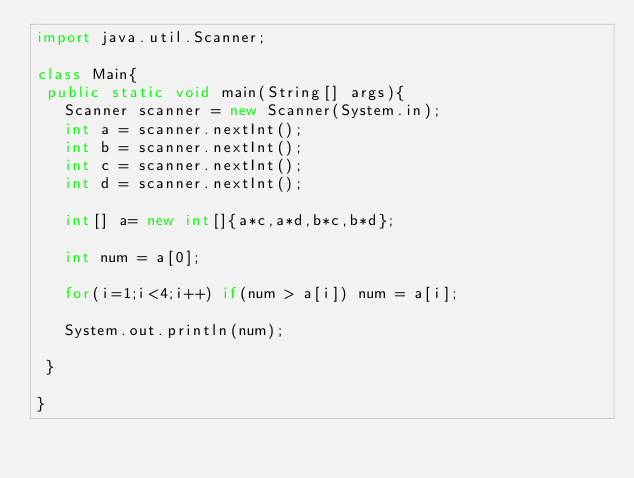Convert code to text. <code><loc_0><loc_0><loc_500><loc_500><_Java_>import java.util.Scanner;
 
class Main{
 public static void main(String[] args){
   Scanner scanner = new Scanner(System.in);
   int a = scanner.nextInt();
   int b = scanner.nextInt();
   int c = scanner.nextInt();
   int d = scanner.nextInt();
   
   int[] a= new int[]{a*c,a*d,b*c,b*d};
   
   int num = a[0];
   
   for(i=1;i<4;i++) if(num > a[i]) num = a[i];
   
   System.out.println(num);
   
 }
   
}</code> 